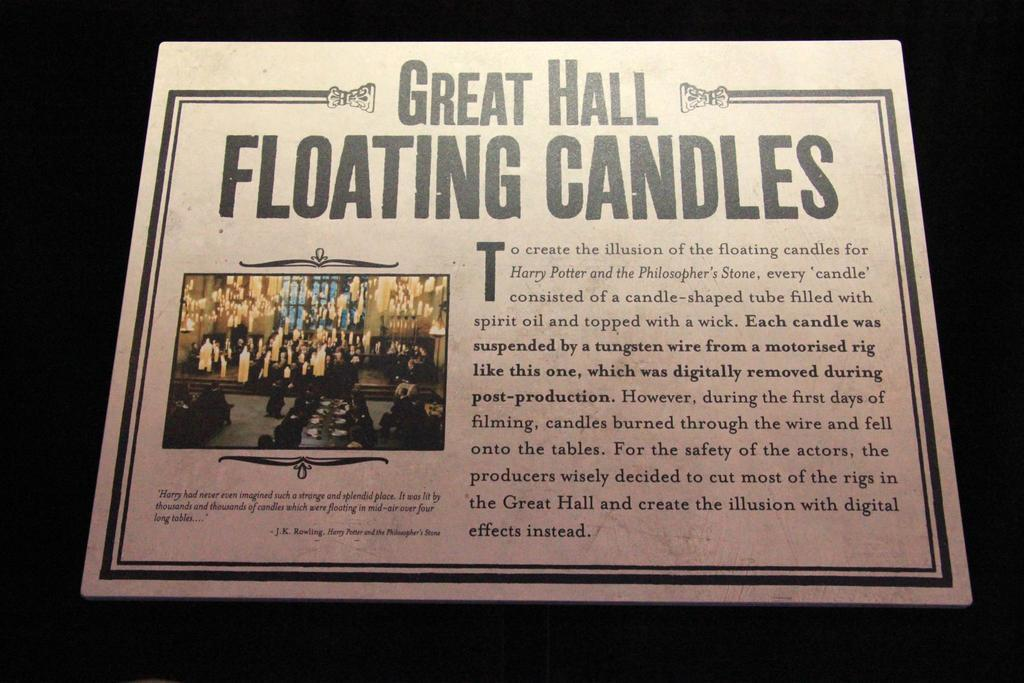<image>
Share a concise interpretation of the image provided. a printed image that reads great hall floating candles. 